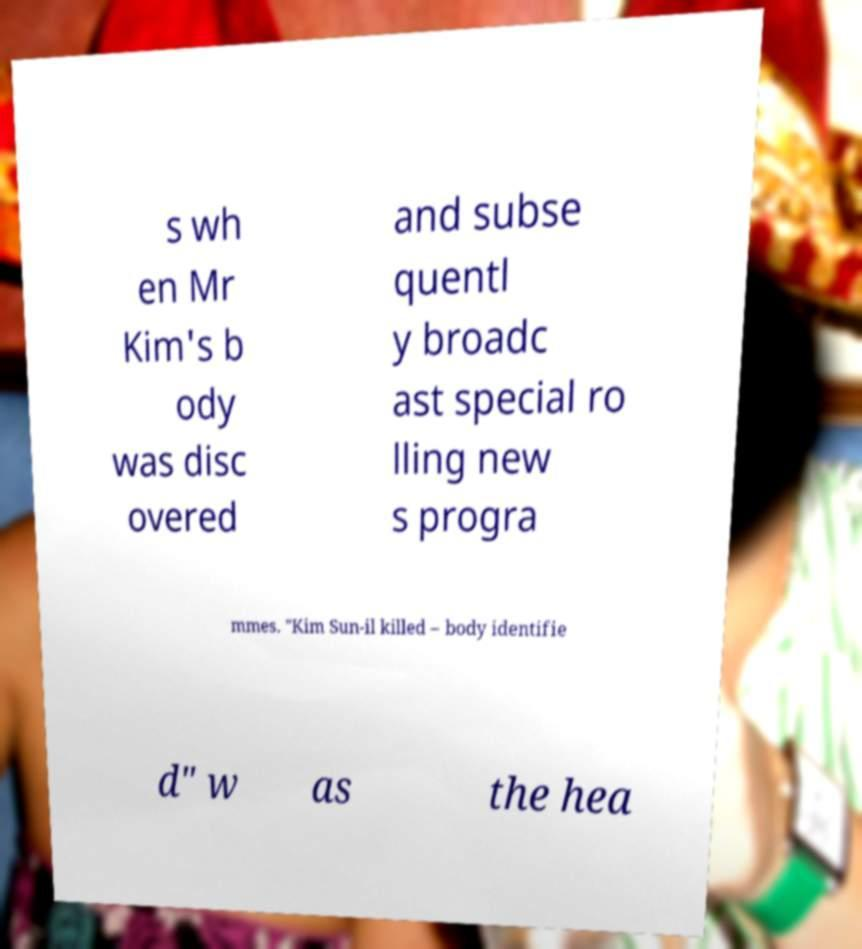There's text embedded in this image that I need extracted. Can you transcribe it verbatim? s wh en Mr Kim's b ody was disc overed and subse quentl y broadc ast special ro lling new s progra mmes. "Kim Sun-il killed – body identifie d" w as the hea 